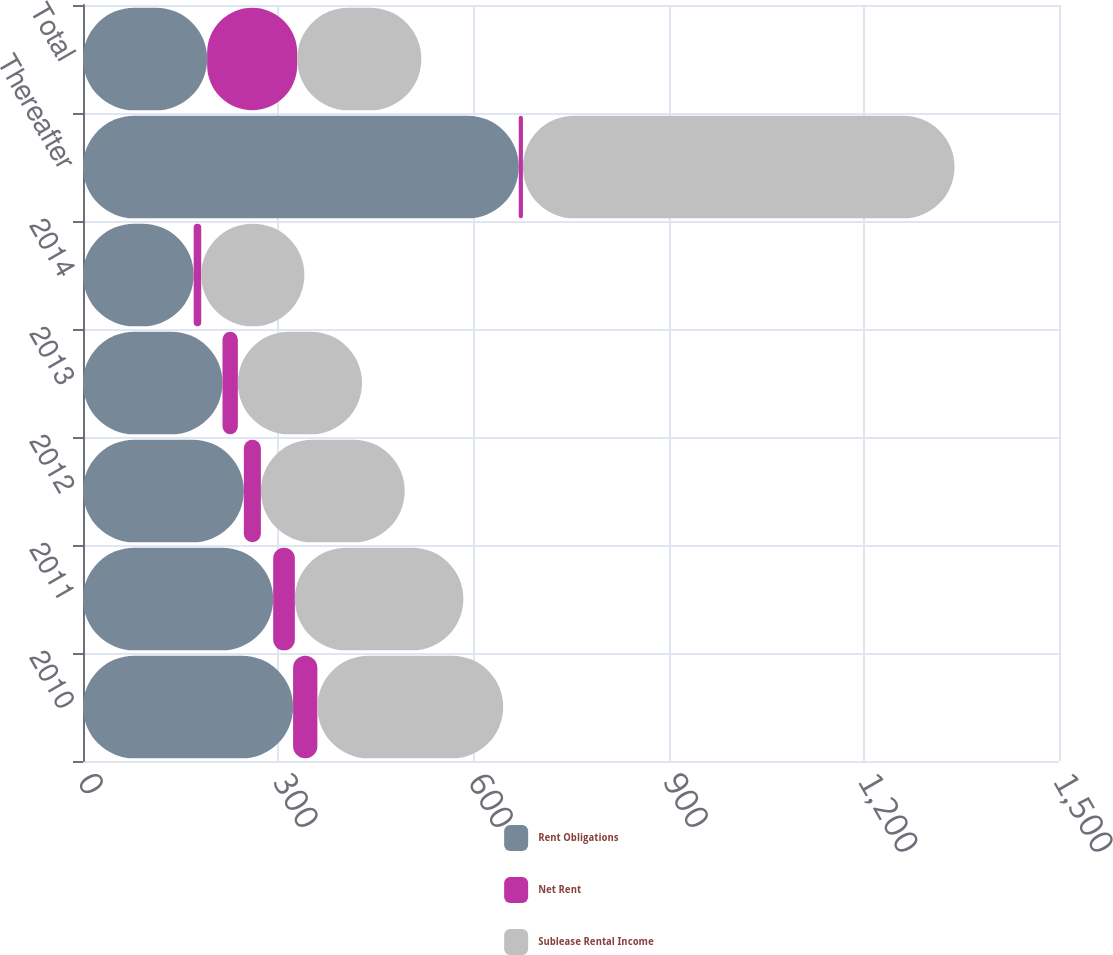<chart> <loc_0><loc_0><loc_500><loc_500><stacked_bar_chart><ecel><fcel>2010<fcel>2011<fcel>2012<fcel>2013<fcel>2014<fcel>Thereafter<fcel>Total<nl><fcel>Rent Obligations<fcel>322.9<fcel>292.3<fcel>247.2<fcel>214.4<fcel>170.1<fcel>669.7<fcel>190.8<nl><fcel>Net Rent<fcel>37.3<fcel>33.3<fcel>26.2<fcel>23.6<fcel>11.6<fcel>6.4<fcel>138.4<nl><fcel>Sublease Rental Income<fcel>285.6<fcel>259<fcel>221<fcel>190.8<fcel>158.5<fcel>663.3<fcel>190.8<nl></chart> 